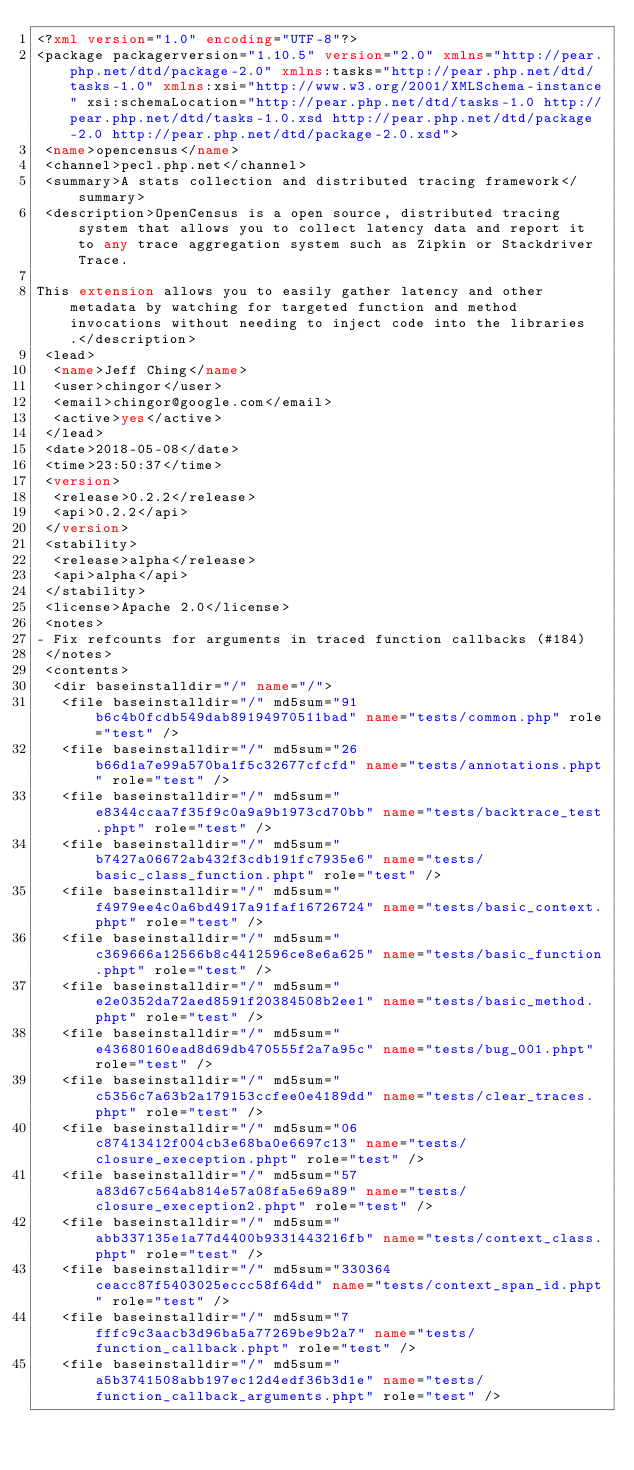<code> <loc_0><loc_0><loc_500><loc_500><_XML_><?xml version="1.0" encoding="UTF-8"?>
<package packagerversion="1.10.5" version="2.0" xmlns="http://pear.php.net/dtd/package-2.0" xmlns:tasks="http://pear.php.net/dtd/tasks-1.0" xmlns:xsi="http://www.w3.org/2001/XMLSchema-instance" xsi:schemaLocation="http://pear.php.net/dtd/tasks-1.0 http://pear.php.net/dtd/tasks-1.0.xsd http://pear.php.net/dtd/package-2.0 http://pear.php.net/dtd/package-2.0.xsd">
 <name>opencensus</name>
 <channel>pecl.php.net</channel>
 <summary>A stats collection and distributed tracing framework</summary>
 <description>OpenCensus is a open source, distributed tracing system that allows you to collect latency data and report it to any trace aggregation system such as Zipkin or Stackdriver Trace.

This extension allows you to easily gather latency and other metadata by watching for targeted function and method invocations without needing to inject code into the libraries.</description>
 <lead>
  <name>Jeff Ching</name>
  <user>chingor</user>
  <email>chingor@google.com</email>
  <active>yes</active>
 </lead>
 <date>2018-05-08</date>
 <time>23:50:37</time>
 <version>
  <release>0.2.2</release>
  <api>0.2.2</api>
 </version>
 <stability>
  <release>alpha</release>
  <api>alpha</api>
 </stability>
 <license>Apache 2.0</license>
 <notes>
- Fix refcounts for arguments in traced function callbacks (#184)
 </notes>
 <contents>
  <dir baseinstalldir="/" name="/">
   <file baseinstalldir="/" md5sum="91b6c4b0fcdb549dab89194970511bad" name="tests/common.php" role="test" />
   <file baseinstalldir="/" md5sum="26b66d1a7e99a570ba1f5c32677cfcfd" name="tests/annotations.phpt" role="test" />
   <file baseinstalldir="/" md5sum="e8344ccaa7f35f9c0a9a9b1973cd70bb" name="tests/backtrace_test.phpt" role="test" />
   <file baseinstalldir="/" md5sum="b7427a06672ab432f3cdb191fc7935e6" name="tests/basic_class_function.phpt" role="test" />
   <file baseinstalldir="/" md5sum="f4979ee4c0a6bd4917a91faf16726724" name="tests/basic_context.phpt" role="test" />
   <file baseinstalldir="/" md5sum="c369666a12566b8c4412596ce8e6a625" name="tests/basic_function.phpt" role="test" />
   <file baseinstalldir="/" md5sum="e2e0352da72aed8591f20384508b2ee1" name="tests/basic_method.phpt" role="test" />
   <file baseinstalldir="/" md5sum="e43680160ead8d69db470555f2a7a95c" name="tests/bug_001.phpt" role="test" />
   <file baseinstalldir="/" md5sum="c5356c7a63b2a179153ccfee0e4189dd" name="tests/clear_traces.phpt" role="test" />
   <file baseinstalldir="/" md5sum="06c87413412f004cb3e68ba0e6697c13" name="tests/closure_exeception.phpt" role="test" />
   <file baseinstalldir="/" md5sum="57a83d67c564ab814e57a08fa5e69a89" name="tests/closure_exeception2.phpt" role="test" />
   <file baseinstalldir="/" md5sum="abb337135e1a77d4400b9331443216fb" name="tests/context_class.phpt" role="test" />
   <file baseinstalldir="/" md5sum="330364ceacc87f5403025eccc58f64dd" name="tests/context_span_id.phpt" role="test" />
   <file baseinstalldir="/" md5sum="7fffc9c3aacb3d96ba5a77269be9b2a7" name="tests/function_callback.phpt" role="test" />
   <file baseinstalldir="/" md5sum="a5b3741508abb197ec12d4edf36b3d1e" name="tests/function_callback_arguments.phpt" role="test" /></code> 